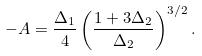Convert formula to latex. <formula><loc_0><loc_0><loc_500><loc_500>- A = \frac { \Delta _ { 1 } } { 4 } \left ( \frac { 1 + 3 \Delta _ { 2 } } { \Delta _ { 2 } } \right ) ^ { 3 / 2 } .</formula> 